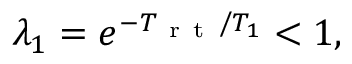Convert formula to latex. <formula><loc_0><loc_0><loc_500><loc_500>\lambda _ { 1 } = e ^ { - T _ { r t } / T _ { 1 } } < 1 ,</formula> 